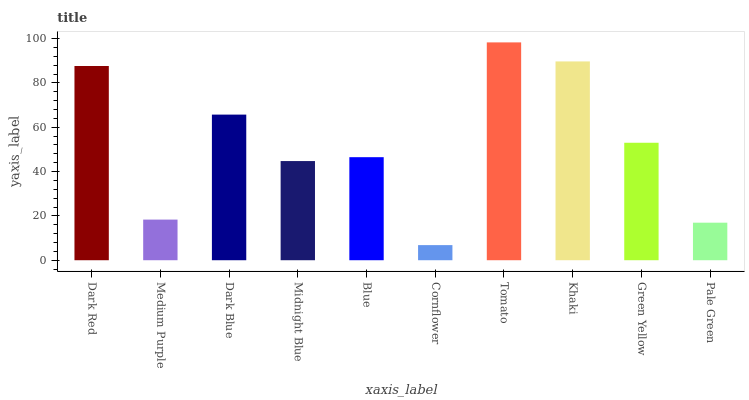Is Cornflower the minimum?
Answer yes or no. Yes. Is Tomato the maximum?
Answer yes or no. Yes. Is Medium Purple the minimum?
Answer yes or no. No. Is Medium Purple the maximum?
Answer yes or no. No. Is Dark Red greater than Medium Purple?
Answer yes or no. Yes. Is Medium Purple less than Dark Red?
Answer yes or no. Yes. Is Medium Purple greater than Dark Red?
Answer yes or no. No. Is Dark Red less than Medium Purple?
Answer yes or no. No. Is Green Yellow the high median?
Answer yes or no. Yes. Is Blue the low median?
Answer yes or no. Yes. Is Khaki the high median?
Answer yes or no. No. Is Pale Green the low median?
Answer yes or no. No. 